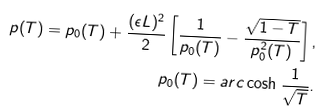<formula> <loc_0><loc_0><loc_500><loc_500>p ( T ) = p _ { 0 } ( T ) + \frac { ( \epsilon L ) ^ { 2 } } { 2 } \left [ \frac { 1 } { p _ { 0 } ( T ) } - \frac { \sqrt { 1 - T } } { p _ { 0 } ^ { 2 } ( T ) } \right ] , \\ p _ { 0 } ( T ) = a r c \cosh \frac { 1 } { \sqrt { T } } .</formula> 